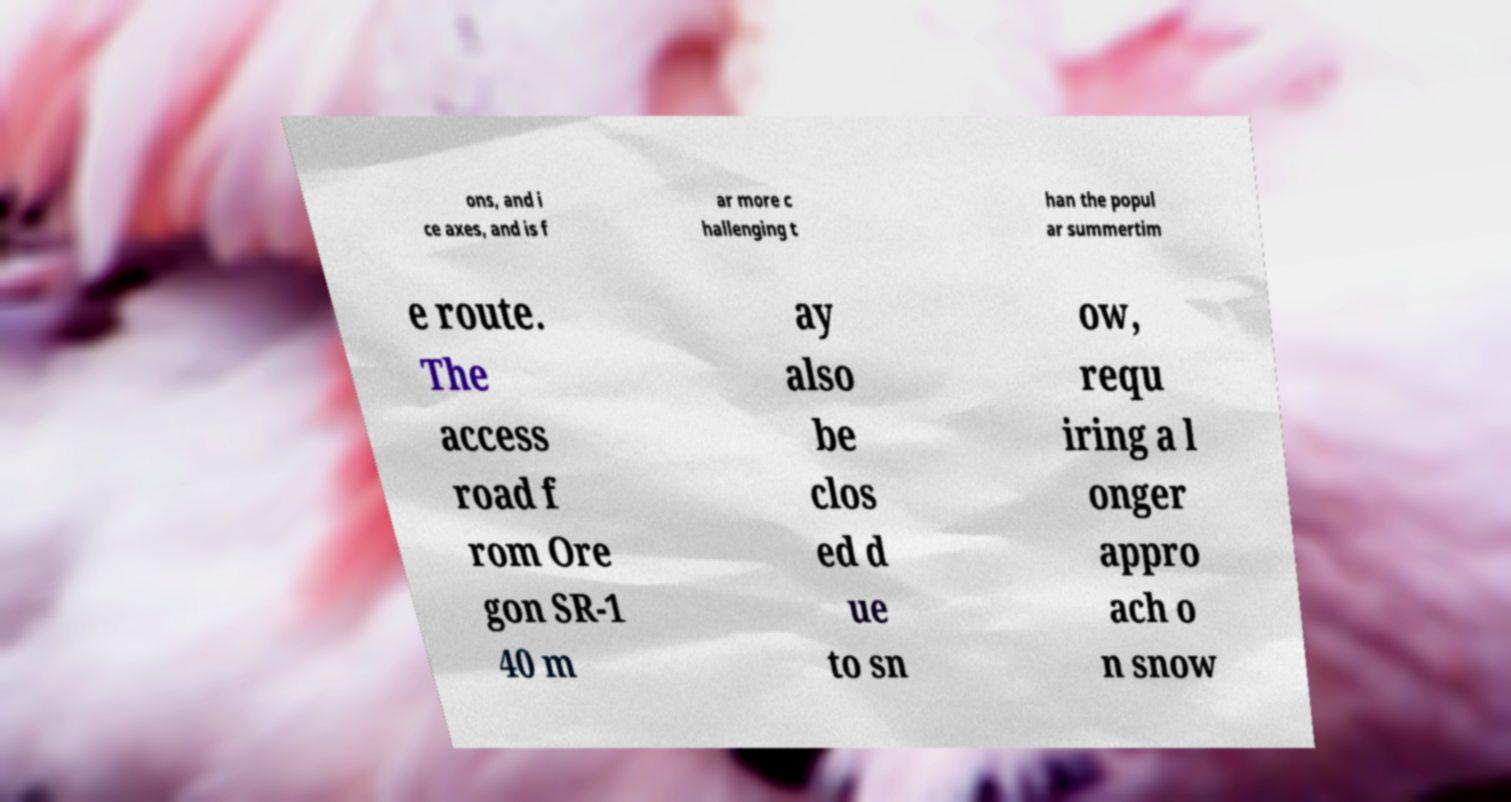What messages or text are displayed in this image? I need them in a readable, typed format. ons, and i ce axes, and is f ar more c hallenging t han the popul ar summertim e route. The access road f rom Ore gon SR-1 40 m ay also be clos ed d ue to sn ow, requ iring a l onger appro ach o n snow 